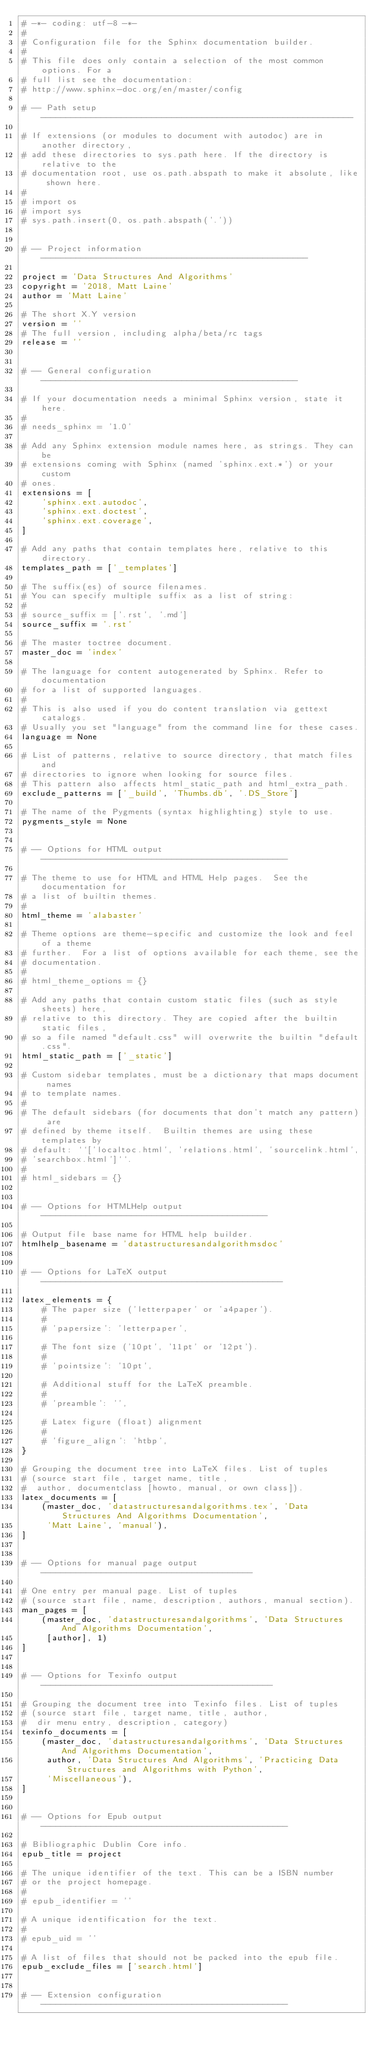<code> <loc_0><loc_0><loc_500><loc_500><_Python_># -*- coding: utf-8 -*-
#
# Configuration file for the Sphinx documentation builder.
#
# This file does only contain a selection of the most common options. For a
# full list see the documentation:
# http://www.sphinx-doc.org/en/master/config

# -- Path setup --------------------------------------------------------------

# If extensions (or modules to document with autodoc) are in another directory,
# add these directories to sys.path here. If the directory is relative to the
# documentation root, use os.path.abspath to make it absolute, like shown here.
#
# import os
# import sys
# sys.path.insert(0, os.path.abspath('.'))


# -- Project information -----------------------------------------------------

project = 'Data Structures And Algorithms'
copyright = '2018, Matt Laine'
author = 'Matt Laine'

# The short X.Y version
version = ''
# The full version, including alpha/beta/rc tags
release = ''


# -- General configuration ---------------------------------------------------

# If your documentation needs a minimal Sphinx version, state it here.
#
# needs_sphinx = '1.0'

# Add any Sphinx extension module names here, as strings. They can be
# extensions coming with Sphinx (named 'sphinx.ext.*') or your custom
# ones.
extensions = [
    'sphinx.ext.autodoc',
    'sphinx.ext.doctest',
    'sphinx.ext.coverage',
]

# Add any paths that contain templates here, relative to this directory.
templates_path = ['_templates']

# The suffix(es) of source filenames.
# You can specify multiple suffix as a list of string:
#
# source_suffix = ['.rst', '.md']
source_suffix = '.rst'

# The master toctree document.
master_doc = 'index'

# The language for content autogenerated by Sphinx. Refer to documentation
# for a list of supported languages.
#
# This is also used if you do content translation via gettext catalogs.
# Usually you set "language" from the command line for these cases.
language = None

# List of patterns, relative to source directory, that match files and
# directories to ignore when looking for source files.
# This pattern also affects html_static_path and html_extra_path.
exclude_patterns = ['_build', 'Thumbs.db', '.DS_Store']

# The name of the Pygments (syntax highlighting) style to use.
pygments_style = None


# -- Options for HTML output -------------------------------------------------

# The theme to use for HTML and HTML Help pages.  See the documentation for
# a list of builtin themes.
#
html_theme = 'alabaster'

# Theme options are theme-specific and customize the look and feel of a theme
# further.  For a list of options available for each theme, see the
# documentation.
#
# html_theme_options = {}

# Add any paths that contain custom static files (such as style sheets) here,
# relative to this directory. They are copied after the builtin static files,
# so a file named "default.css" will overwrite the builtin "default.css".
html_static_path = ['_static']

# Custom sidebar templates, must be a dictionary that maps document names
# to template names.
#
# The default sidebars (for documents that don't match any pattern) are
# defined by theme itself.  Builtin themes are using these templates by
# default: ``['localtoc.html', 'relations.html', 'sourcelink.html',
# 'searchbox.html']``.
#
# html_sidebars = {}


# -- Options for HTMLHelp output ---------------------------------------------

# Output file base name for HTML help builder.
htmlhelp_basename = 'datastructuresandalgorithmsdoc'


# -- Options for LaTeX output ------------------------------------------------

latex_elements = {
    # The paper size ('letterpaper' or 'a4paper').
    #
    # 'papersize': 'letterpaper',

    # The font size ('10pt', '11pt' or '12pt').
    #
    # 'pointsize': '10pt',

    # Additional stuff for the LaTeX preamble.
    #
    # 'preamble': '',

    # Latex figure (float) alignment
    #
    # 'figure_align': 'htbp',
}

# Grouping the document tree into LaTeX files. List of tuples
# (source start file, target name, title,
#  author, documentclass [howto, manual, or own class]).
latex_documents = [
    (master_doc, 'datastructuresandalgorithms.tex', 'Data Structures And Algorithms Documentation',
     'Matt Laine', 'manual'),
]


# -- Options for manual page output ------------------------------------------

# One entry per manual page. List of tuples
# (source start file, name, description, authors, manual section).
man_pages = [
    (master_doc, 'datastructuresandalgorithms', 'Data Structures And Algorithms Documentation',
     [author], 1)
]


# -- Options for Texinfo output ----------------------------------------------

# Grouping the document tree into Texinfo files. List of tuples
# (source start file, target name, title, author,
#  dir menu entry, description, category)
texinfo_documents = [
    (master_doc, 'datastructuresandalgorithms', 'Data Structures And Algorithms Documentation',
     author, 'Data Structures And Algorithms', 'Practicing Data Structures and Algorithms with Python',
     'Miscellaneous'),
]


# -- Options for Epub output -------------------------------------------------

# Bibliographic Dublin Core info.
epub_title = project

# The unique identifier of the text. This can be a ISBN number
# or the project homepage.
#
# epub_identifier = ''

# A unique identification for the text.
#
# epub_uid = ''

# A list of files that should not be packed into the epub file.
epub_exclude_files = ['search.html']


# -- Extension configuration -------------------------------------------------</code> 